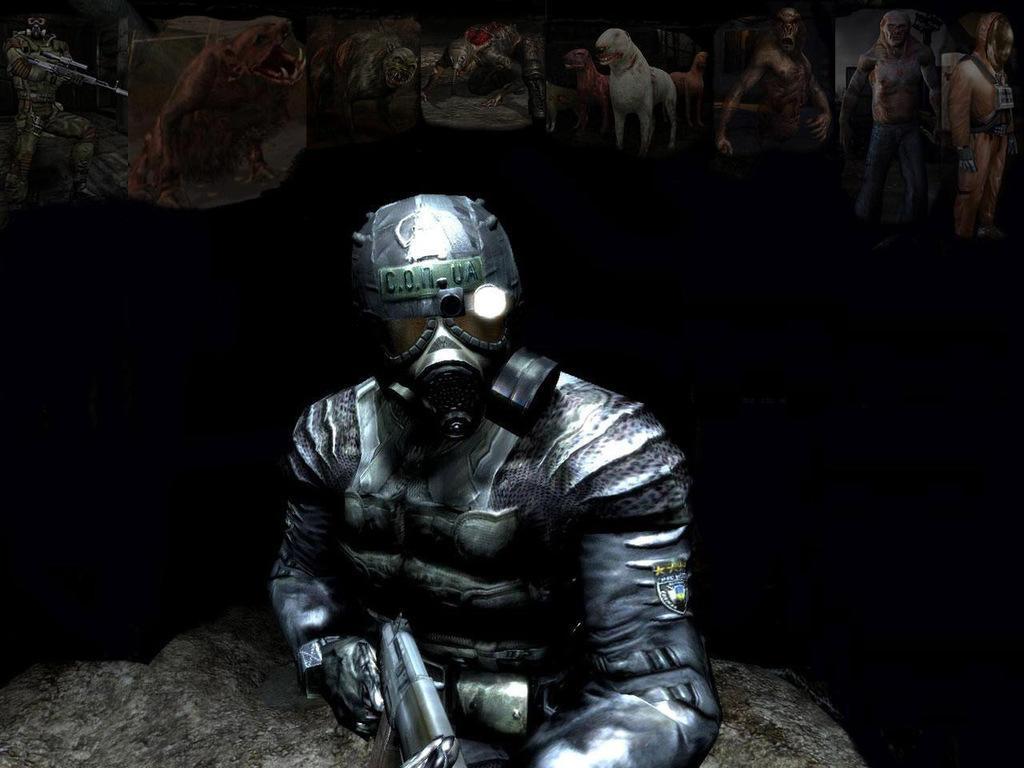Please provide a concise description of this image. This is an animated picture. In the foreground of the picture there is a person wearing mask and holding a gun. At the top there are animals and people. The background is dark. 